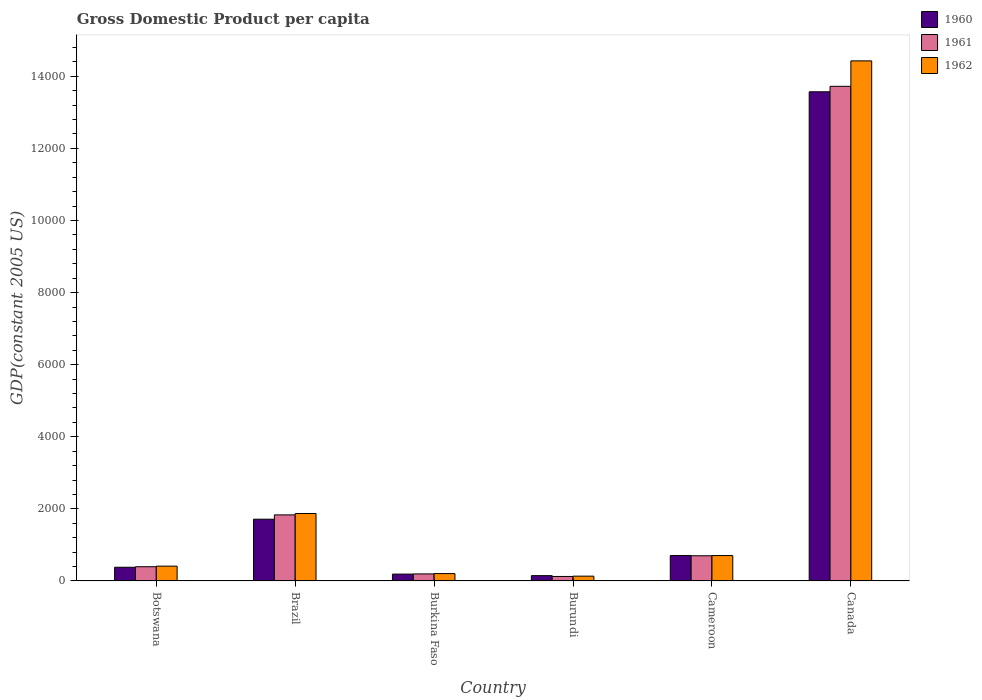How many different coloured bars are there?
Offer a terse response. 3. How many groups of bars are there?
Give a very brief answer. 6. Are the number of bars on each tick of the X-axis equal?
Offer a very short reply. Yes. How many bars are there on the 2nd tick from the left?
Your answer should be compact. 3. How many bars are there on the 6th tick from the right?
Your answer should be very brief. 3. What is the label of the 5th group of bars from the left?
Make the answer very short. Cameroon. What is the GDP per capita in 1962 in Burkina Faso?
Make the answer very short. 204.13. Across all countries, what is the maximum GDP per capita in 1961?
Your answer should be compact. 1.37e+04. Across all countries, what is the minimum GDP per capita in 1962?
Provide a succinct answer. 133.14. In which country was the GDP per capita in 1960 minimum?
Provide a succinct answer. Burundi. What is the total GDP per capita in 1960 in the graph?
Your response must be concise. 1.67e+04. What is the difference between the GDP per capita in 1960 in Botswana and that in Burkina Faso?
Make the answer very short. 189.87. What is the difference between the GDP per capita in 1961 in Burkina Faso and the GDP per capita in 1960 in Canada?
Keep it short and to the point. -1.34e+04. What is the average GDP per capita in 1960 per country?
Make the answer very short. 2784.15. What is the difference between the GDP per capita of/in 1960 and GDP per capita of/in 1961 in Burkina Faso?
Provide a short and direct response. -5.04. In how many countries, is the GDP per capita in 1961 greater than 1200 US$?
Provide a short and direct response. 2. What is the ratio of the GDP per capita in 1962 in Botswana to that in Burkina Faso?
Make the answer very short. 2.01. Is the GDP per capita in 1960 in Brazil less than that in Burundi?
Your answer should be compact. No. What is the difference between the highest and the second highest GDP per capita in 1962?
Provide a short and direct response. -1.37e+04. What is the difference between the highest and the lowest GDP per capita in 1961?
Your response must be concise. 1.36e+04. In how many countries, is the GDP per capita in 1961 greater than the average GDP per capita in 1961 taken over all countries?
Your answer should be compact. 1. What does the 1st bar from the left in Brazil represents?
Your response must be concise. 1960. What does the 2nd bar from the right in Canada represents?
Your answer should be very brief. 1961. What is the difference between two consecutive major ticks on the Y-axis?
Your answer should be compact. 2000. Does the graph contain any zero values?
Offer a terse response. No. Does the graph contain grids?
Offer a terse response. No. Where does the legend appear in the graph?
Provide a succinct answer. Top right. What is the title of the graph?
Your answer should be very brief. Gross Domestic Product per capita. What is the label or title of the X-axis?
Your response must be concise. Country. What is the label or title of the Y-axis?
Keep it short and to the point. GDP(constant 2005 US). What is the GDP(constant 2005 US) in 1960 in Botswana?
Give a very brief answer. 379.75. What is the GDP(constant 2005 US) of 1961 in Botswana?
Give a very brief answer. 394.4. What is the GDP(constant 2005 US) of 1962 in Botswana?
Your response must be concise. 410.43. What is the GDP(constant 2005 US) of 1960 in Brazil?
Ensure brevity in your answer.  1712.76. What is the GDP(constant 2005 US) in 1961 in Brazil?
Provide a succinct answer. 1832.81. What is the GDP(constant 2005 US) of 1962 in Brazil?
Provide a succinct answer. 1870.8. What is the GDP(constant 2005 US) of 1960 in Burkina Faso?
Give a very brief answer. 189.88. What is the GDP(constant 2005 US) of 1961 in Burkina Faso?
Your answer should be compact. 194.93. What is the GDP(constant 2005 US) in 1962 in Burkina Faso?
Make the answer very short. 204.13. What is the GDP(constant 2005 US) in 1960 in Burundi?
Ensure brevity in your answer.  147.01. What is the GDP(constant 2005 US) of 1961 in Burundi?
Your answer should be very brief. 124.4. What is the GDP(constant 2005 US) in 1962 in Burundi?
Provide a short and direct response. 133.14. What is the GDP(constant 2005 US) of 1960 in Cameroon?
Your answer should be very brief. 704.77. What is the GDP(constant 2005 US) in 1961 in Cameroon?
Your response must be concise. 698.37. What is the GDP(constant 2005 US) of 1962 in Cameroon?
Your answer should be very brief. 704.27. What is the GDP(constant 2005 US) in 1960 in Canada?
Keep it short and to the point. 1.36e+04. What is the GDP(constant 2005 US) of 1961 in Canada?
Keep it short and to the point. 1.37e+04. What is the GDP(constant 2005 US) in 1962 in Canada?
Provide a succinct answer. 1.44e+04. Across all countries, what is the maximum GDP(constant 2005 US) of 1960?
Provide a succinct answer. 1.36e+04. Across all countries, what is the maximum GDP(constant 2005 US) of 1961?
Ensure brevity in your answer.  1.37e+04. Across all countries, what is the maximum GDP(constant 2005 US) of 1962?
Ensure brevity in your answer.  1.44e+04. Across all countries, what is the minimum GDP(constant 2005 US) of 1960?
Ensure brevity in your answer.  147.01. Across all countries, what is the minimum GDP(constant 2005 US) in 1961?
Provide a succinct answer. 124.4. Across all countries, what is the minimum GDP(constant 2005 US) in 1962?
Offer a terse response. 133.14. What is the total GDP(constant 2005 US) of 1960 in the graph?
Offer a very short reply. 1.67e+04. What is the total GDP(constant 2005 US) in 1961 in the graph?
Your answer should be very brief. 1.70e+04. What is the total GDP(constant 2005 US) of 1962 in the graph?
Your response must be concise. 1.78e+04. What is the difference between the GDP(constant 2005 US) of 1960 in Botswana and that in Brazil?
Provide a short and direct response. -1333.01. What is the difference between the GDP(constant 2005 US) of 1961 in Botswana and that in Brazil?
Offer a very short reply. -1438.41. What is the difference between the GDP(constant 2005 US) of 1962 in Botswana and that in Brazil?
Your response must be concise. -1460.36. What is the difference between the GDP(constant 2005 US) in 1960 in Botswana and that in Burkina Faso?
Your answer should be very brief. 189.87. What is the difference between the GDP(constant 2005 US) in 1961 in Botswana and that in Burkina Faso?
Keep it short and to the point. 199.47. What is the difference between the GDP(constant 2005 US) of 1962 in Botswana and that in Burkina Faso?
Provide a short and direct response. 206.3. What is the difference between the GDP(constant 2005 US) of 1960 in Botswana and that in Burundi?
Offer a very short reply. 232.75. What is the difference between the GDP(constant 2005 US) in 1961 in Botswana and that in Burundi?
Provide a short and direct response. 270. What is the difference between the GDP(constant 2005 US) of 1962 in Botswana and that in Burundi?
Keep it short and to the point. 277.29. What is the difference between the GDP(constant 2005 US) in 1960 in Botswana and that in Cameroon?
Provide a short and direct response. -325.01. What is the difference between the GDP(constant 2005 US) in 1961 in Botswana and that in Cameroon?
Ensure brevity in your answer.  -303.97. What is the difference between the GDP(constant 2005 US) of 1962 in Botswana and that in Cameroon?
Provide a succinct answer. -293.84. What is the difference between the GDP(constant 2005 US) in 1960 in Botswana and that in Canada?
Ensure brevity in your answer.  -1.32e+04. What is the difference between the GDP(constant 2005 US) in 1961 in Botswana and that in Canada?
Give a very brief answer. -1.33e+04. What is the difference between the GDP(constant 2005 US) of 1962 in Botswana and that in Canada?
Keep it short and to the point. -1.40e+04. What is the difference between the GDP(constant 2005 US) in 1960 in Brazil and that in Burkina Faso?
Your answer should be very brief. 1522.88. What is the difference between the GDP(constant 2005 US) in 1961 in Brazil and that in Burkina Faso?
Ensure brevity in your answer.  1637.88. What is the difference between the GDP(constant 2005 US) of 1962 in Brazil and that in Burkina Faso?
Your response must be concise. 1666.67. What is the difference between the GDP(constant 2005 US) of 1960 in Brazil and that in Burundi?
Make the answer very short. 1565.76. What is the difference between the GDP(constant 2005 US) in 1961 in Brazil and that in Burundi?
Offer a terse response. 1708.4. What is the difference between the GDP(constant 2005 US) of 1962 in Brazil and that in Burundi?
Your answer should be compact. 1737.65. What is the difference between the GDP(constant 2005 US) of 1960 in Brazil and that in Cameroon?
Your answer should be very brief. 1008. What is the difference between the GDP(constant 2005 US) in 1961 in Brazil and that in Cameroon?
Provide a short and direct response. 1134.44. What is the difference between the GDP(constant 2005 US) of 1962 in Brazil and that in Cameroon?
Your answer should be very brief. 1166.52. What is the difference between the GDP(constant 2005 US) of 1960 in Brazil and that in Canada?
Your answer should be compact. -1.19e+04. What is the difference between the GDP(constant 2005 US) in 1961 in Brazil and that in Canada?
Make the answer very short. -1.19e+04. What is the difference between the GDP(constant 2005 US) of 1962 in Brazil and that in Canada?
Offer a very short reply. -1.26e+04. What is the difference between the GDP(constant 2005 US) of 1960 in Burkina Faso and that in Burundi?
Ensure brevity in your answer.  42.88. What is the difference between the GDP(constant 2005 US) in 1961 in Burkina Faso and that in Burundi?
Ensure brevity in your answer.  70.52. What is the difference between the GDP(constant 2005 US) of 1962 in Burkina Faso and that in Burundi?
Your answer should be compact. 70.99. What is the difference between the GDP(constant 2005 US) of 1960 in Burkina Faso and that in Cameroon?
Offer a very short reply. -514.89. What is the difference between the GDP(constant 2005 US) of 1961 in Burkina Faso and that in Cameroon?
Your response must be concise. -503.45. What is the difference between the GDP(constant 2005 US) in 1962 in Burkina Faso and that in Cameroon?
Provide a short and direct response. -500.14. What is the difference between the GDP(constant 2005 US) in 1960 in Burkina Faso and that in Canada?
Make the answer very short. -1.34e+04. What is the difference between the GDP(constant 2005 US) in 1961 in Burkina Faso and that in Canada?
Give a very brief answer. -1.35e+04. What is the difference between the GDP(constant 2005 US) in 1962 in Burkina Faso and that in Canada?
Give a very brief answer. -1.42e+04. What is the difference between the GDP(constant 2005 US) in 1960 in Burundi and that in Cameroon?
Your answer should be compact. -557.76. What is the difference between the GDP(constant 2005 US) of 1961 in Burundi and that in Cameroon?
Your answer should be very brief. -573.97. What is the difference between the GDP(constant 2005 US) in 1962 in Burundi and that in Cameroon?
Provide a succinct answer. -571.13. What is the difference between the GDP(constant 2005 US) of 1960 in Burundi and that in Canada?
Ensure brevity in your answer.  -1.34e+04. What is the difference between the GDP(constant 2005 US) of 1961 in Burundi and that in Canada?
Offer a terse response. -1.36e+04. What is the difference between the GDP(constant 2005 US) in 1962 in Burundi and that in Canada?
Provide a short and direct response. -1.43e+04. What is the difference between the GDP(constant 2005 US) in 1960 in Cameroon and that in Canada?
Provide a succinct answer. -1.29e+04. What is the difference between the GDP(constant 2005 US) of 1961 in Cameroon and that in Canada?
Your answer should be very brief. -1.30e+04. What is the difference between the GDP(constant 2005 US) of 1962 in Cameroon and that in Canada?
Make the answer very short. -1.37e+04. What is the difference between the GDP(constant 2005 US) of 1960 in Botswana and the GDP(constant 2005 US) of 1961 in Brazil?
Offer a very short reply. -1453.05. What is the difference between the GDP(constant 2005 US) of 1960 in Botswana and the GDP(constant 2005 US) of 1962 in Brazil?
Ensure brevity in your answer.  -1491.04. What is the difference between the GDP(constant 2005 US) in 1961 in Botswana and the GDP(constant 2005 US) in 1962 in Brazil?
Make the answer very short. -1476.4. What is the difference between the GDP(constant 2005 US) in 1960 in Botswana and the GDP(constant 2005 US) in 1961 in Burkina Faso?
Your response must be concise. 184.83. What is the difference between the GDP(constant 2005 US) of 1960 in Botswana and the GDP(constant 2005 US) of 1962 in Burkina Faso?
Give a very brief answer. 175.62. What is the difference between the GDP(constant 2005 US) in 1961 in Botswana and the GDP(constant 2005 US) in 1962 in Burkina Faso?
Your answer should be compact. 190.27. What is the difference between the GDP(constant 2005 US) of 1960 in Botswana and the GDP(constant 2005 US) of 1961 in Burundi?
Give a very brief answer. 255.35. What is the difference between the GDP(constant 2005 US) of 1960 in Botswana and the GDP(constant 2005 US) of 1962 in Burundi?
Ensure brevity in your answer.  246.61. What is the difference between the GDP(constant 2005 US) of 1961 in Botswana and the GDP(constant 2005 US) of 1962 in Burundi?
Your answer should be very brief. 261.26. What is the difference between the GDP(constant 2005 US) of 1960 in Botswana and the GDP(constant 2005 US) of 1961 in Cameroon?
Give a very brief answer. -318.62. What is the difference between the GDP(constant 2005 US) of 1960 in Botswana and the GDP(constant 2005 US) of 1962 in Cameroon?
Your answer should be compact. -324.52. What is the difference between the GDP(constant 2005 US) of 1961 in Botswana and the GDP(constant 2005 US) of 1962 in Cameroon?
Your response must be concise. -309.87. What is the difference between the GDP(constant 2005 US) in 1960 in Botswana and the GDP(constant 2005 US) in 1961 in Canada?
Offer a very short reply. -1.33e+04. What is the difference between the GDP(constant 2005 US) of 1960 in Botswana and the GDP(constant 2005 US) of 1962 in Canada?
Ensure brevity in your answer.  -1.40e+04. What is the difference between the GDP(constant 2005 US) in 1961 in Botswana and the GDP(constant 2005 US) in 1962 in Canada?
Make the answer very short. -1.40e+04. What is the difference between the GDP(constant 2005 US) in 1960 in Brazil and the GDP(constant 2005 US) in 1961 in Burkina Faso?
Your response must be concise. 1517.84. What is the difference between the GDP(constant 2005 US) in 1960 in Brazil and the GDP(constant 2005 US) in 1962 in Burkina Faso?
Offer a terse response. 1508.63. What is the difference between the GDP(constant 2005 US) of 1961 in Brazil and the GDP(constant 2005 US) of 1962 in Burkina Faso?
Keep it short and to the point. 1628.68. What is the difference between the GDP(constant 2005 US) in 1960 in Brazil and the GDP(constant 2005 US) in 1961 in Burundi?
Offer a very short reply. 1588.36. What is the difference between the GDP(constant 2005 US) in 1960 in Brazil and the GDP(constant 2005 US) in 1962 in Burundi?
Offer a terse response. 1579.62. What is the difference between the GDP(constant 2005 US) of 1961 in Brazil and the GDP(constant 2005 US) of 1962 in Burundi?
Your answer should be compact. 1699.67. What is the difference between the GDP(constant 2005 US) in 1960 in Brazil and the GDP(constant 2005 US) in 1961 in Cameroon?
Your answer should be very brief. 1014.39. What is the difference between the GDP(constant 2005 US) of 1960 in Brazil and the GDP(constant 2005 US) of 1962 in Cameroon?
Offer a terse response. 1008.49. What is the difference between the GDP(constant 2005 US) of 1961 in Brazil and the GDP(constant 2005 US) of 1962 in Cameroon?
Your answer should be very brief. 1128.54. What is the difference between the GDP(constant 2005 US) in 1960 in Brazil and the GDP(constant 2005 US) in 1961 in Canada?
Make the answer very short. -1.20e+04. What is the difference between the GDP(constant 2005 US) in 1960 in Brazil and the GDP(constant 2005 US) in 1962 in Canada?
Provide a succinct answer. -1.27e+04. What is the difference between the GDP(constant 2005 US) of 1961 in Brazil and the GDP(constant 2005 US) of 1962 in Canada?
Your answer should be compact. -1.26e+04. What is the difference between the GDP(constant 2005 US) in 1960 in Burkina Faso and the GDP(constant 2005 US) in 1961 in Burundi?
Provide a short and direct response. 65.48. What is the difference between the GDP(constant 2005 US) in 1960 in Burkina Faso and the GDP(constant 2005 US) in 1962 in Burundi?
Give a very brief answer. 56.74. What is the difference between the GDP(constant 2005 US) in 1961 in Burkina Faso and the GDP(constant 2005 US) in 1962 in Burundi?
Provide a succinct answer. 61.78. What is the difference between the GDP(constant 2005 US) in 1960 in Burkina Faso and the GDP(constant 2005 US) in 1961 in Cameroon?
Your response must be concise. -508.49. What is the difference between the GDP(constant 2005 US) in 1960 in Burkina Faso and the GDP(constant 2005 US) in 1962 in Cameroon?
Your response must be concise. -514.39. What is the difference between the GDP(constant 2005 US) in 1961 in Burkina Faso and the GDP(constant 2005 US) in 1962 in Cameroon?
Your answer should be compact. -509.35. What is the difference between the GDP(constant 2005 US) of 1960 in Burkina Faso and the GDP(constant 2005 US) of 1961 in Canada?
Offer a terse response. -1.35e+04. What is the difference between the GDP(constant 2005 US) in 1960 in Burkina Faso and the GDP(constant 2005 US) in 1962 in Canada?
Offer a terse response. -1.42e+04. What is the difference between the GDP(constant 2005 US) in 1961 in Burkina Faso and the GDP(constant 2005 US) in 1962 in Canada?
Your answer should be compact. -1.42e+04. What is the difference between the GDP(constant 2005 US) in 1960 in Burundi and the GDP(constant 2005 US) in 1961 in Cameroon?
Provide a succinct answer. -551.37. What is the difference between the GDP(constant 2005 US) in 1960 in Burundi and the GDP(constant 2005 US) in 1962 in Cameroon?
Your answer should be compact. -557.26. What is the difference between the GDP(constant 2005 US) of 1961 in Burundi and the GDP(constant 2005 US) of 1962 in Cameroon?
Provide a short and direct response. -579.87. What is the difference between the GDP(constant 2005 US) in 1960 in Burundi and the GDP(constant 2005 US) in 1961 in Canada?
Your answer should be compact. -1.36e+04. What is the difference between the GDP(constant 2005 US) in 1960 in Burundi and the GDP(constant 2005 US) in 1962 in Canada?
Offer a terse response. -1.43e+04. What is the difference between the GDP(constant 2005 US) of 1961 in Burundi and the GDP(constant 2005 US) of 1962 in Canada?
Ensure brevity in your answer.  -1.43e+04. What is the difference between the GDP(constant 2005 US) of 1960 in Cameroon and the GDP(constant 2005 US) of 1961 in Canada?
Provide a short and direct response. -1.30e+04. What is the difference between the GDP(constant 2005 US) of 1960 in Cameroon and the GDP(constant 2005 US) of 1962 in Canada?
Your answer should be compact. -1.37e+04. What is the difference between the GDP(constant 2005 US) of 1961 in Cameroon and the GDP(constant 2005 US) of 1962 in Canada?
Your answer should be compact. -1.37e+04. What is the average GDP(constant 2005 US) in 1960 per country?
Ensure brevity in your answer.  2784.15. What is the average GDP(constant 2005 US) in 1961 per country?
Give a very brief answer. 2827.92. What is the average GDP(constant 2005 US) of 1962 per country?
Provide a succinct answer. 2958.52. What is the difference between the GDP(constant 2005 US) in 1960 and GDP(constant 2005 US) in 1961 in Botswana?
Give a very brief answer. -14.65. What is the difference between the GDP(constant 2005 US) of 1960 and GDP(constant 2005 US) of 1962 in Botswana?
Ensure brevity in your answer.  -30.68. What is the difference between the GDP(constant 2005 US) of 1961 and GDP(constant 2005 US) of 1962 in Botswana?
Your response must be concise. -16.03. What is the difference between the GDP(constant 2005 US) in 1960 and GDP(constant 2005 US) in 1961 in Brazil?
Your response must be concise. -120.04. What is the difference between the GDP(constant 2005 US) of 1960 and GDP(constant 2005 US) of 1962 in Brazil?
Make the answer very short. -158.03. What is the difference between the GDP(constant 2005 US) of 1961 and GDP(constant 2005 US) of 1962 in Brazil?
Make the answer very short. -37.99. What is the difference between the GDP(constant 2005 US) in 1960 and GDP(constant 2005 US) in 1961 in Burkina Faso?
Your answer should be compact. -5.04. What is the difference between the GDP(constant 2005 US) in 1960 and GDP(constant 2005 US) in 1962 in Burkina Faso?
Offer a terse response. -14.25. What is the difference between the GDP(constant 2005 US) of 1961 and GDP(constant 2005 US) of 1962 in Burkina Faso?
Offer a very short reply. -9.2. What is the difference between the GDP(constant 2005 US) in 1960 and GDP(constant 2005 US) in 1961 in Burundi?
Your answer should be very brief. 22.6. What is the difference between the GDP(constant 2005 US) in 1960 and GDP(constant 2005 US) in 1962 in Burundi?
Ensure brevity in your answer.  13.86. What is the difference between the GDP(constant 2005 US) in 1961 and GDP(constant 2005 US) in 1962 in Burundi?
Give a very brief answer. -8.74. What is the difference between the GDP(constant 2005 US) of 1960 and GDP(constant 2005 US) of 1961 in Cameroon?
Your answer should be compact. 6.4. What is the difference between the GDP(constant 2005 US) in 1960 and GDP(constant 2005 US) in 1962 in Cameroon?
Give a very brief answer. 0.5. What is the difference between the GDP(constant 2005 US) of 1961 and GDP(constant 2005 US) of 1962 in Cameroon?
Ensure brevity in your answer.  -5.9. What is the difference between the GDP(constant 2005 US) of 1960 and GDP(constant 2005 US) of 1961 in Canada?
Make the answer very short. -151.91. What is the difference between the GDP(constant 2005 US) of 1960 and GDP(constant 2005 US) of 1962 in Canada?
Provide a short and direct response. -857.65. What is the difference between the GDP(constant 2005 US) in 1961 and GDP(constant 2005 US) in 1962 in Canada?
Your response must be concise. -705.75. What is the ratio of the GDP(constant 2005 US) in 1960 in Botswana to that in Brazil?
Make the answer very short. 0.22. What is the ratio of the GDP(constant 2005 US) in 1961 in Botswana to that in Brazil?
Offer a terse response. 0.22. What is the ratio of the GDP(constant 2005 US) of 1962 in Botswana to that in Brazil?
Ensure brevity in your answer.  0.22. What is the ratio of the GDP(constant 2005 US) in 1961 in Botswana to that in Burkina Faso?
Offer a very short reply. 2.02. What is the ratio of the GDP(constant 2005 US) of 1962 in Botswana to that in Burkina Faso?
Keep it short and to the point. 2.01. What is the ratio of the GDP(constant 2005 US) of 1960 in Botswana to that in Burundi?
Your response must be concise. 2.58. What is the ratio of the GDP(constant 2005 US) of 1961 in Botswana to that in Burundi?
Ensure brevity in your answer.  3.17. What is the ratio of the GDP(constant 2005 US) of 1962 in Botswana to that in Burundi?
Give a very brief answer. 3.08. What is the ratio of the GDP(constant 2005 US) of 1960 in Botswana to that in Cameroon?
Keep it short and to the point. 0.54. What is the ratio of the GDP(constant 2005 US) in 1961 in Botswana to that in Cameroon?
Ensure brevity in your answer.  0.56. What is the ratio of the GDP(constant 2005 US) in 1962 in Botswana to that in Cameroon?
Offer a terse response. 0.58. What is the ratio of the GDP(constant 2005 US) of 1960 in Botswana to that in Canada?
Keep it short and to the point. 0.03. What is the ratio of the GDP(constant 2005 US) in 1961 in Botswana to that in Canada?
Your answer should be very brief. 0.03. What is the ratio of the GDP(constant 2005 US) of 1962 in Botswana to that in Canada?
Provide a short and direct response. 0.03. What is the ratio of the GDP(constant 2005 US) of 1960 in Brazil to that in Burkina Faso?
Ensure brevity in your answer.  9.02. What is the ratio of the GDP(constant 2005 US) in 1961 in Brazil to that in Burkina Faso?
Make the answer very short. 9.4. What is the ratio of the GDP(constant 2005 US) of 1962 in Brazil to that in Burkina Faso?
Your answer should be very brief. 9.16. What is the ratio of the GDP(constant 2005 US) of 1960 in Brazil to that in Burundi?
Your response must be concise. 11.65. What is the ratio of the GDP(constant 2005 US) of 1961 in Brazil to that in Burundi?
Make the answer very short. 14.73. What is the ratio of the GDP(constant 2005 US) of 1962 in Brazil to that in Burundi?
Your answer should be very brief. 14.05. What is the ratio of the GDP(constant 2005 US) of 1960 in Brazil to that in Cameroon?
Make the answer very short. 2.43. What is the ratio of the GDP(constant 2005 US) of 1961 in Brazil to that in Cameroon?
Offer a very short reply. 2.62. What is the ratio of the GDP(constant 2005 US) in 1962 in Brazil to that in Cameroon?
Your answer should be very brief. 2.66. What is the ratio of the GDP(constant 2005 US) of 1960 in Brazil to that in Canada?
Provide a succinct answer. 0.13. What is the ratio of the GDP(constant 2005 US) of 1961 in Brazil to that in Canada?
Your response must be concise. 0.13. What is the ratio of the GDP(constant 2005 US) in 1962 in Brazil to that in Canada?
Your response must be concise. 0.13. What is the ratio of the GDP(constant 2005 US) of 1960 in Burkina Faso to that in Burundi?
Provide a short and direct response. 1.29. What is the ratio of the GDP(constant 2005 US) of 1961 in Burkina Faso to that in Burundi?
Provide a short and direct response. 1.57. What is the ratio of the GDP(constant 2005 US) of 1962 in Burkina Faso to that in Burundi?
Ensure brevity in your answer.  1.53. What is the ratio of the GDP(constant 2005 US) in 1960 in Burkina Faso to that in Cameroon?
Provide a short and direct response. 0.27. What is the ratio of the GDP(constant 2005 US) in 1961 in Burkina Faso to that in Cameroon?
Give a very brief answer. 0.28. What is the ratio of the GDP(constant 2005 US) in 1962 in Burkina Faso to that in Cameroon?
Provide a short and direct response. 0.29. What is the ratio of the GDP(constant 2005 US) of 1960 in Burkina Faso to that in Canada?
Ensure brevity in your answer.  0.01. What is the ratio of the GDP(constant 2005 US) in 1961 in Burkina Faso to that in Canada?
Keep it short and to the point. 0.01. What is the ratio of the GDP(constant 2005 US) of 1962 in Burkina Faso to that in Canada?
Ensure brevity in your answer.  0.01. What is the ratio of the GDP(constant 2005 US) of 1960 in Burundi to that in Cameroon?
Provide a short and direct response. 0.21. What is the ratio of the GDP(constant 2005 US) in 1961 in Burundi to that in Cameroon?
Keep it short and to the point. 0.18. What is the ratio of the GDP(constant 2005 US) of 1962 in Burundi to that in Cameroon?
Keep it short and to the point. 0.19. What is the ratio of the GDP(constant 2005 US) of 1960 in Burundi to that in Canada?
Give a very brief answer. 0.01. What is the ratio of the GDP(constant 2005 US) in 1961 in Burundi to that in Canada?
Provide a short and direct response. 0.01. What is the ratio of the GDP(constant 2005 US) in 1962 in Burundi to that in Canada?
Offer a very short reply. 0.01. What is the ratio of the GDP(constant 2005 US) in 1960 in Cameroon to that in Canada?
Provide a short and direct response. 0.05. What is the ratio of the GDP(constant 2005 US) in 1961 in Cameroon to that in Canada?
Your response must be concise. 0.05. What is the ratio of the GDP(constant 2005 US) of 1962 in Cameroon to that in Canada?
Your answer should be very brief. 0.05. What is the difference between the highest and the second highest GDP(constant 2005 US) in 1960?
Your answer should be very brief. 1.19e+04. What is the difference between the highest and the second highest GDP(constant 2005 US) in 1961?
Keep it short and to the point. 1.19e+04. What is the difference between the highest and the second highest GDP(constant 2005 US) of 1962?
Provide a succinct answer. 1.26e+04. What is the difference between the highest and the lowest GDP(constant 2005 US) in 1960?
Provide a succinct answer. 1.34e+04. What is the difference between the highest and the lowest GDP(constant 2005 US) of 1961?
Your answer should be very brief. 1.36e+04. What is the difference between the highest and the lowest GDP(constant 2005 US) in 1962?
Offer a very short reply. 1.43e+04. 